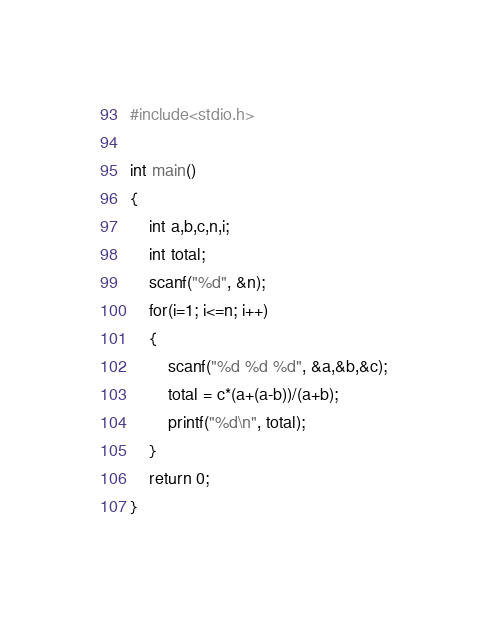<code> <loc_0><loc_0><loc_500><loc_500><_C_>#include<stdio.h>

int main()
{
    int a,b,c,n,i;
    int total;
    scanf("%d", &n);
    for(i=1; i<=n; i++)
    {
        scanf("%d %d %d", &a,&b,&c);
        total = c*(a+(a-b))/(a+b);
        printf("%d\n", total);
    }
    return 0;
}
</code> 